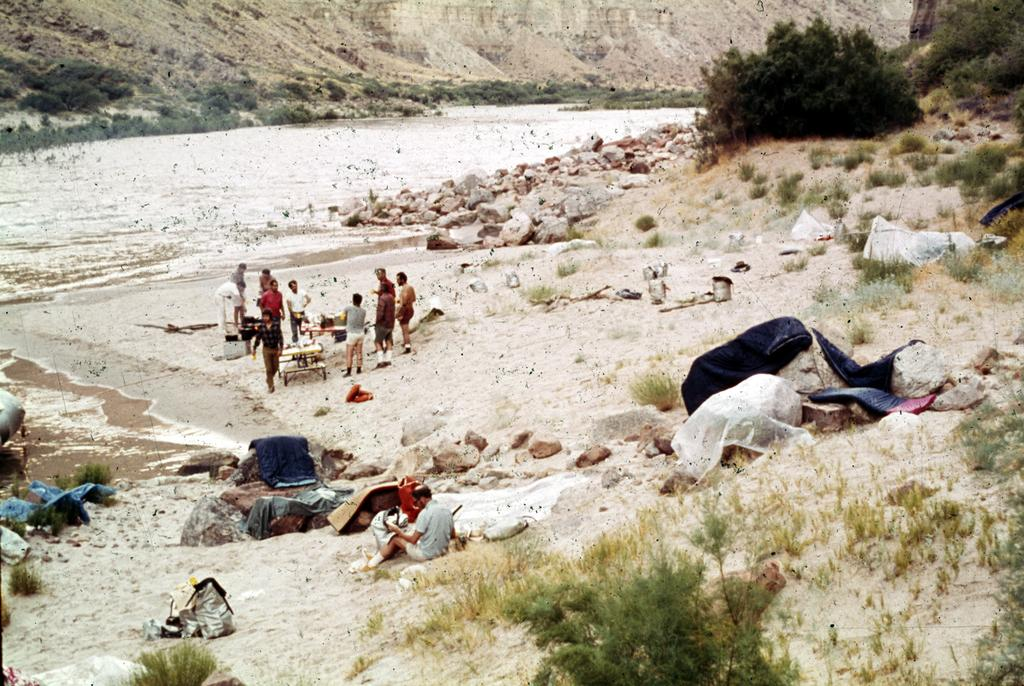What is visible in the image? Water, rocks, people, tables, plants, and grass are visible in the image. Can you describe the setting in which the people are located? The people are located in an area with water, rocks, plants, and grass. What type of objects are the tables used for in the image? The tables are used for holding unspecified "things" in the image. Where is the cobweb located in the image? There is no cobweb present in the image. What type of cactus can be seen growing among the rocks in the image? There is no cactus present in the image. 